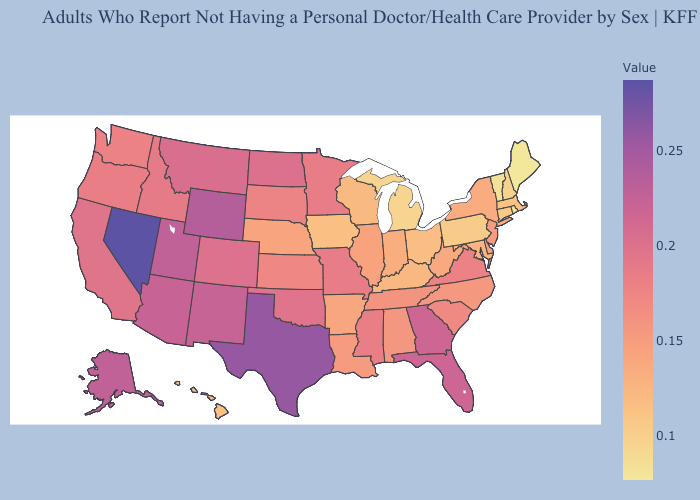Does Michigan have the highest value in the MidWest?
Give a very brief answer. No. Which states have the lowest value in the Northeast?
Give a very brief answer. Maine. Among the states that border Nebraska , does Iowa have the lowest value?
Short answer required. Yes. Does the map have missing data?
Keep it brief. No. Among the states that border Missouri , does Tennessee have the highest value?
Give a very brief answer. No. Among the states that border New Hampshire , which have the highest value?
Be succinct. Massachusetts. 